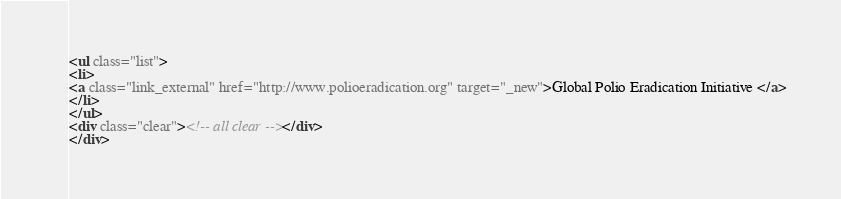Convert code to text. <code><loc_0><loc_0><loc_500><loc_500><_HTML_><ul class="list">
<li>
<a class="link_external" href="http://www.polioeradication.org" target="_new">Global Polio Eradication Initiative </a>
</li>
</ul>
<div class="clear"><!-- all clear --></div>
</div></code> 